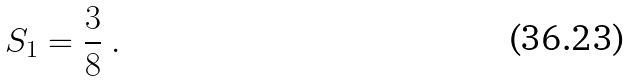<formula> <loc_0><loc_0><loc_500><loc_500>S _ { 1 } = \frac { 3 } { 8 } \ .</formula> 